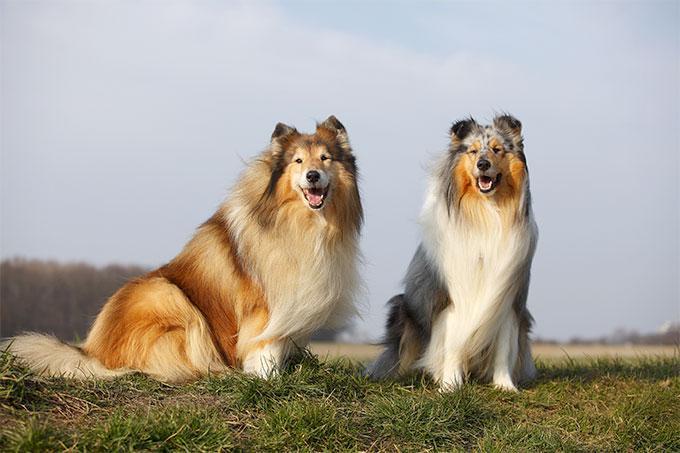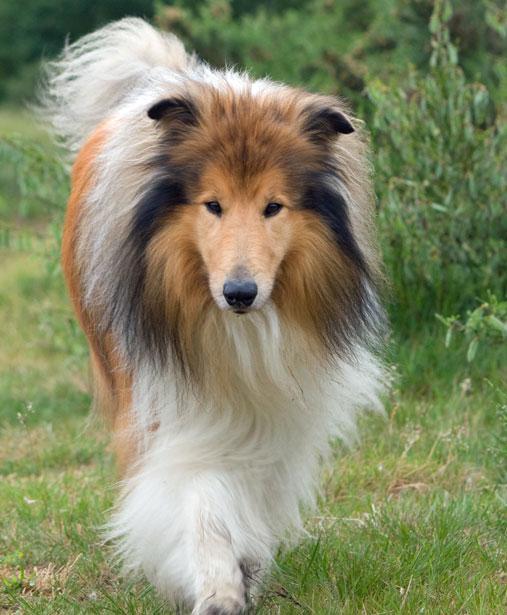The first image is the image on the left, the second image is the image on the right. Examine the images to the left and right. Is the description "The dog in the image on the right is moving toward the camera" accurate? Answer yes or no. Yes. 